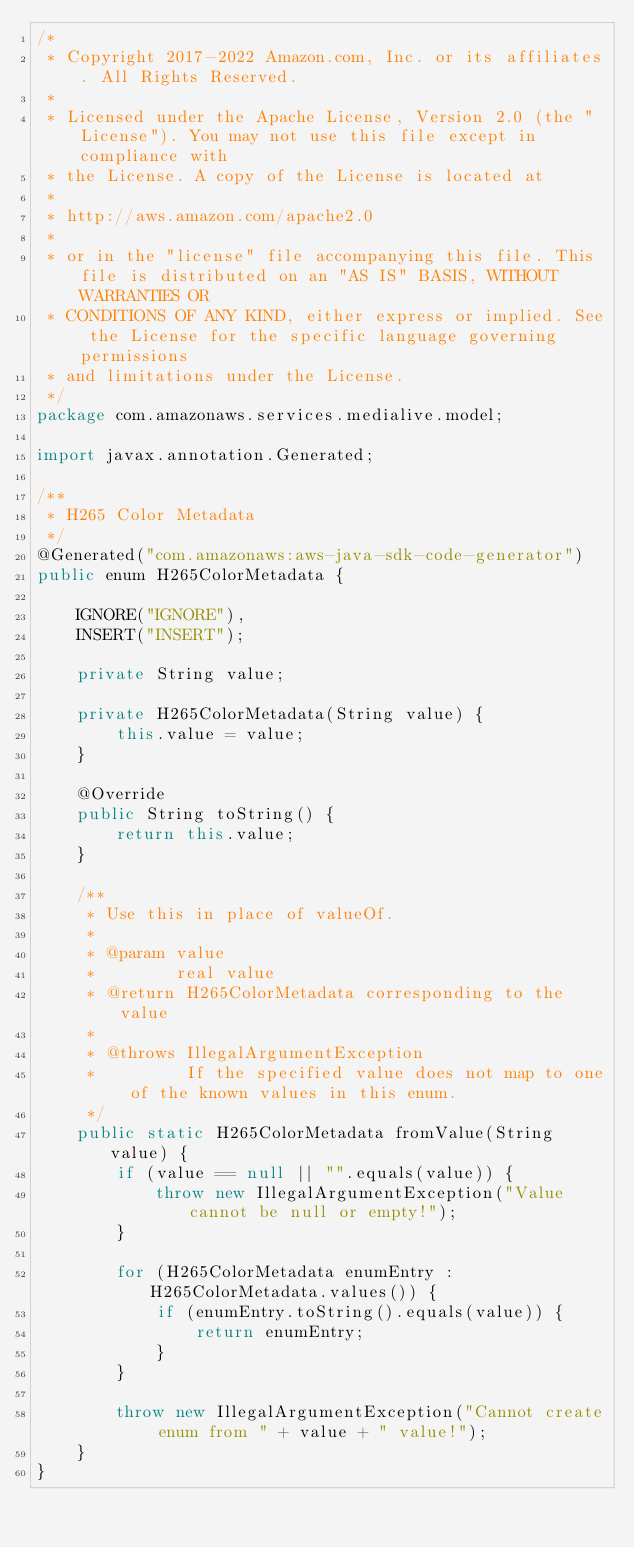<code> <loc_0><loc_0><loc_500><loc_500><_Java_>/*
 * Copyright 2017-2022 Amazon.com, Inc. or its affiliates. All Rights Reserved.
 * 
 * Licensed under the Apache License, Version 2.0 (the "License"). You may not use this file except in compliance with
 * the License. A copy of the License is located at
 * 
 * http://aws.amazon.com/apache2.0
 * 
 * or in the "license" file accompanying this file. This file is distributed on an "AS IS" BASIS, WITHOUT WARRANTIES OR
 * CONDITIONS OF ANY KIND, either express or implied. See the License for the specific language governing permissions
 * and limitations under the License.
 */
package com.amazonaws.services.medialive.model;

import javax.annotation.Generated;

/**
 * H265 Color Metadata
 */
@Generated("com.amazonaws:aws-java-sdk-code-generator")
public enum H265ColorMetadata {

    IGNORE("IGNORE"),
    INSERT("INSERT");

    private String value;

    private H265ColorMetadata(String value) {
        this.value = value;
    }

    @Override
    public String toString() {
        return this.value;
    }

    /**
     * Use this in place of valueOf.
     *
     * @param value
     *        real value
     * @return H265ColorMetadata corresponding to the value
     *
     * @throws IllegalArgumentException
     *         If the specified value does not map to one of the known values in this enum.
     */
    public static H265ColorMetadata fromValue(String value) {
        if (value == null || "".equals(value)) {
            throw new IllegalArgumentException("Value cannot be null or empty!");
        }

        for (H265ColorMetadata enumEntry : H265ColorMetadata.values()) {
            if (enumEntry.toString().equals(value)) {
                return enumEntry;
            }
        }

        throw new IllegalArgumentException("Cannot create enum from " + value + " value!");
    }
}
</code> 